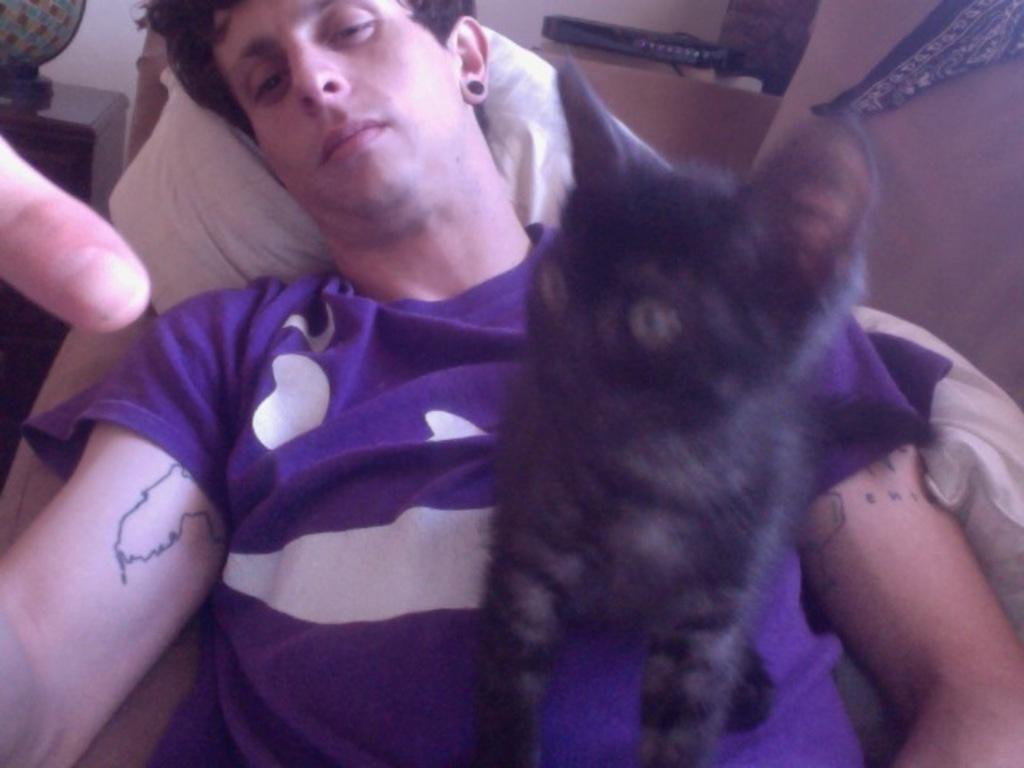Describe this image in one or two sentences. In this image in the center there is one person who is lying, and on the person there is one cat. And in the background there is a table, cloth, pillows, bed and some other objects. 